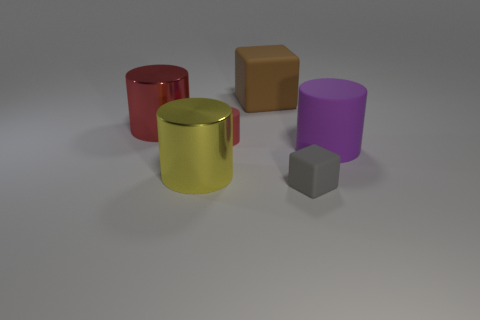Are there any big objects on the right side of the shiny cylinder behind the red rubber cylinder?
Provide a succinct answer. Yes. Is there a gray cylinder that has the same size as the purple thing?
Offer a very short reply. No. There is a large rubber object on the right side of the tiny block; does it have the same color as the tiny rubber block?
Provide a succinct answer. No. The yellow object is what size?
Keep it short and to the point. Large. There is a shiny cylinder behind the rubber thing on the right side of the gray cube; what is its size?
Offer a terse response. Large. What number of big metal things have the same color as the tiny rubber cylinder?
Keep it short and to the point. 1. What number of large blue matte blocks are there?
Provide a succinct answer. 0. How many large yellow cylinders have the same material as the gray cube?
Your response must be concise. 0. The gray thing that is the same shape as the brown rubber thing is what size?
Ensure brevity in your answer.  Small. What is the material of the big yellow cylinder?
Ensure brevity in your answer.  Metal. 